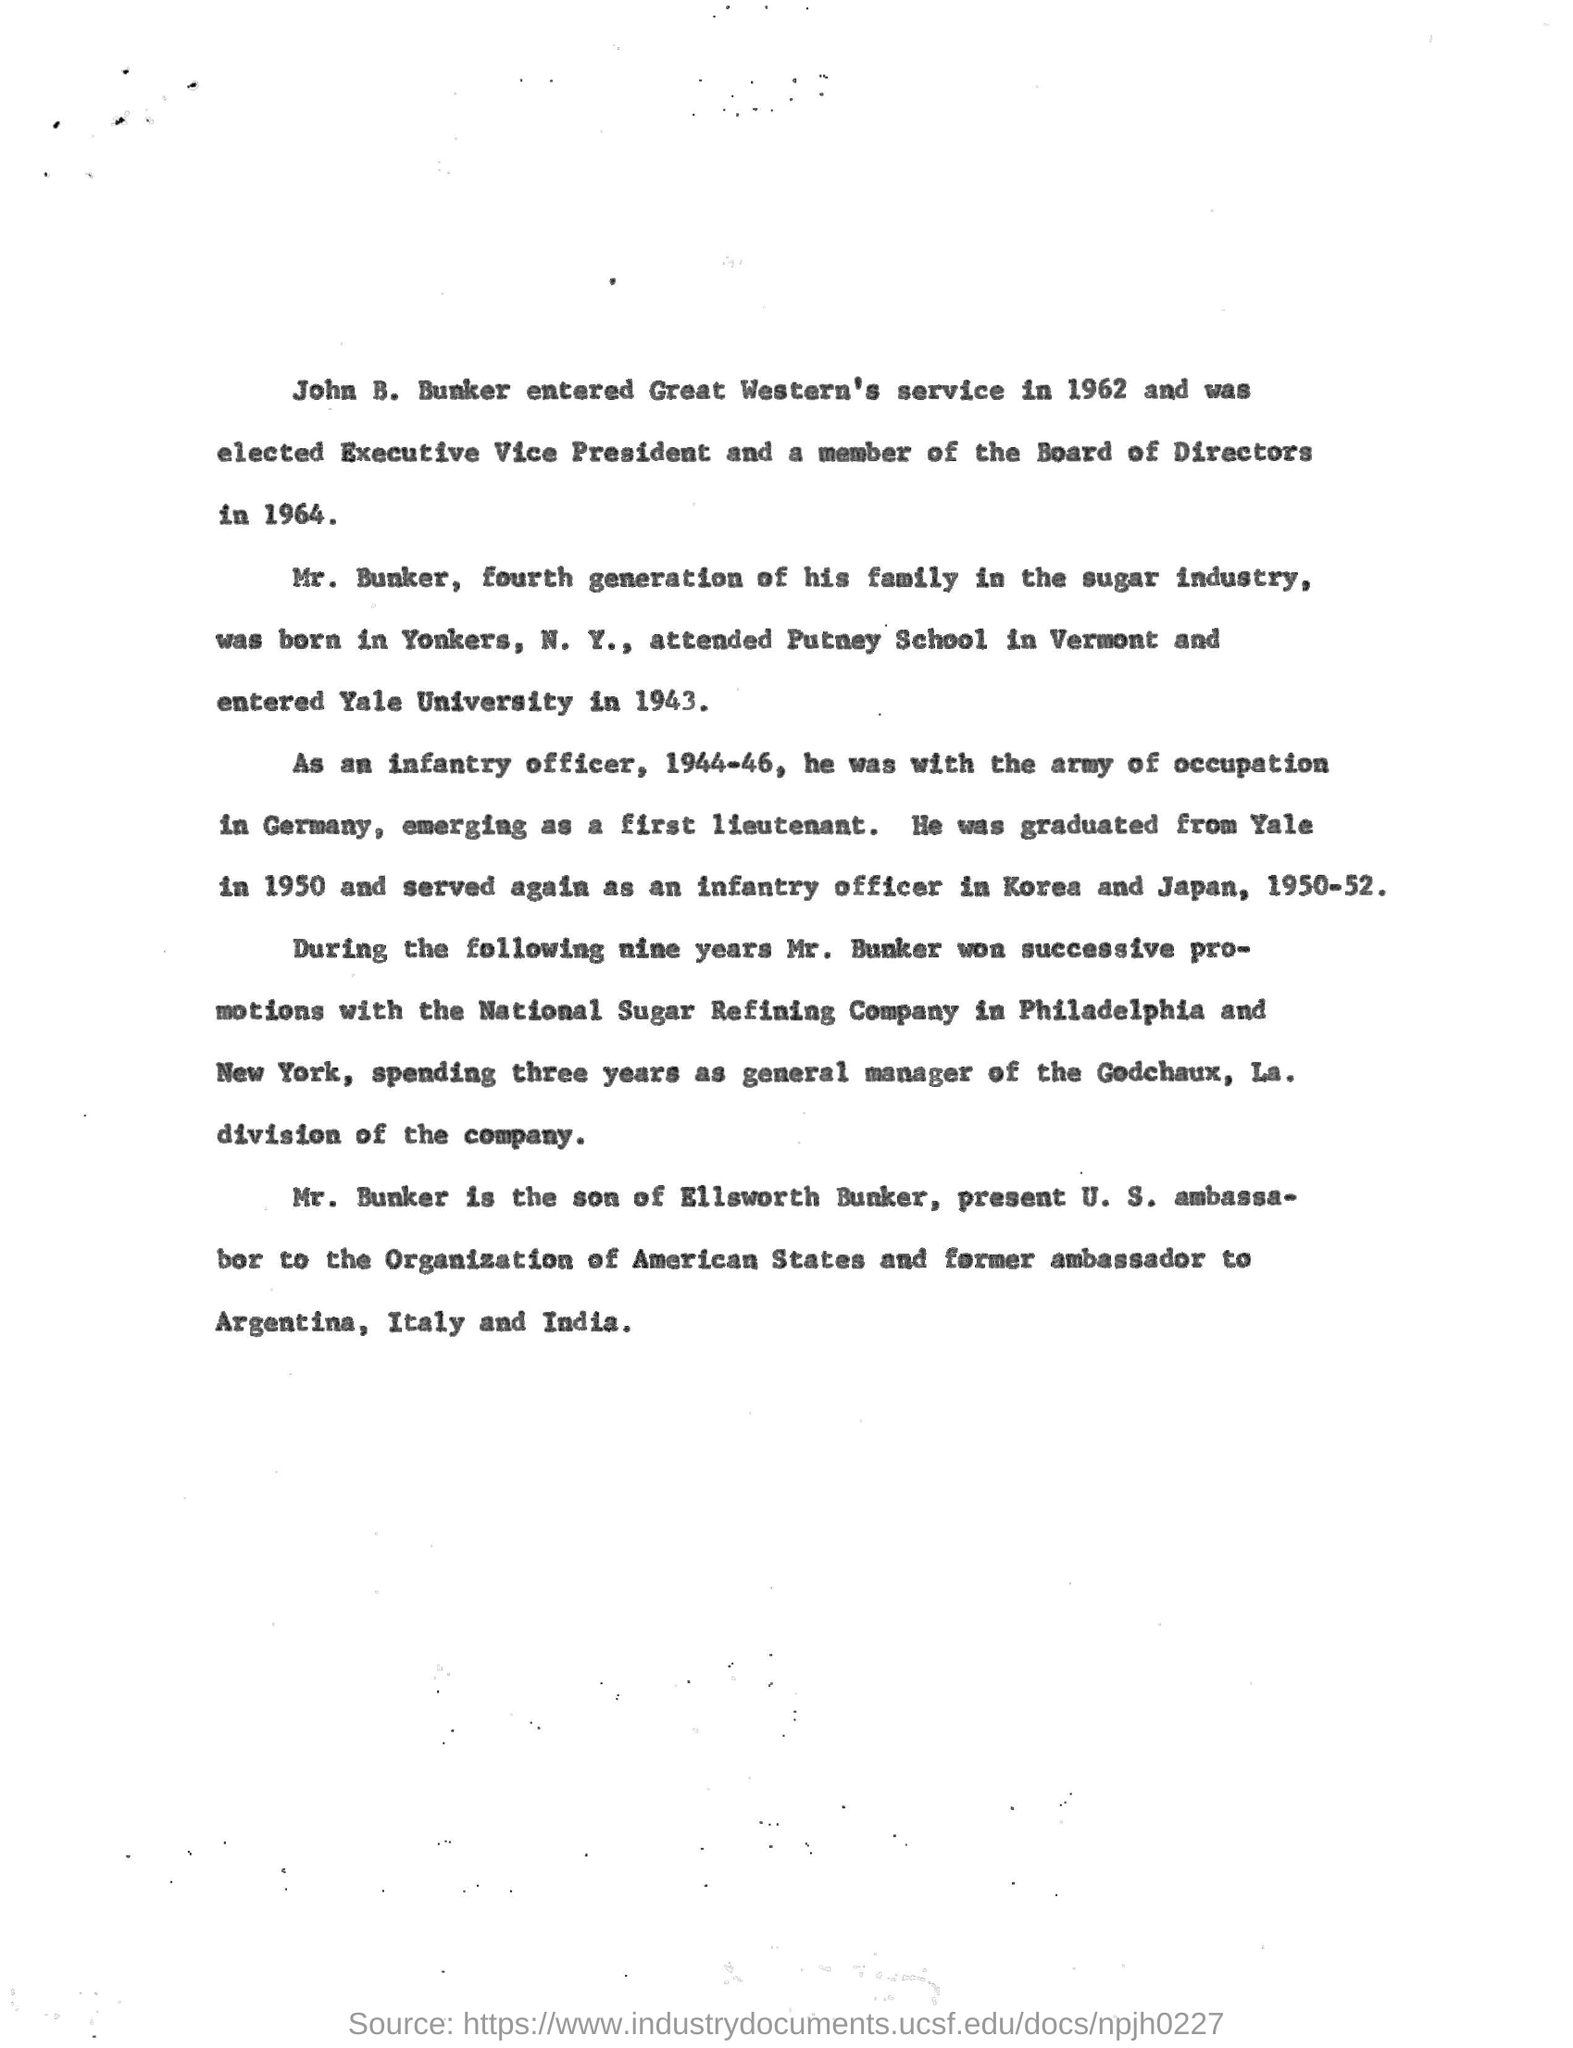Who entered the Great Western's service in 1962?
Ensure brevity in your answer.  John B. Bunker. Who was elected as Executive Vice President in 1964?
Your answer should be compact. John B. Bunker. Which generation of his family does Mr. Bunker belong to in the sugar industry
Provide a succinct answer. Fourth. Where was Mr.Bunker born?
Ensure brevity in your answer.  Yonkers, N. Y. When did John B. Bunker entered Yale university?
Provide a succinct answer. In 1943. In which university, John B. Bunker did his graduation?
Provide a succinct answer. Yale University. Who was the son of Ellsworth Bunker?
Your answer should be very brief. John B. Bunker. 